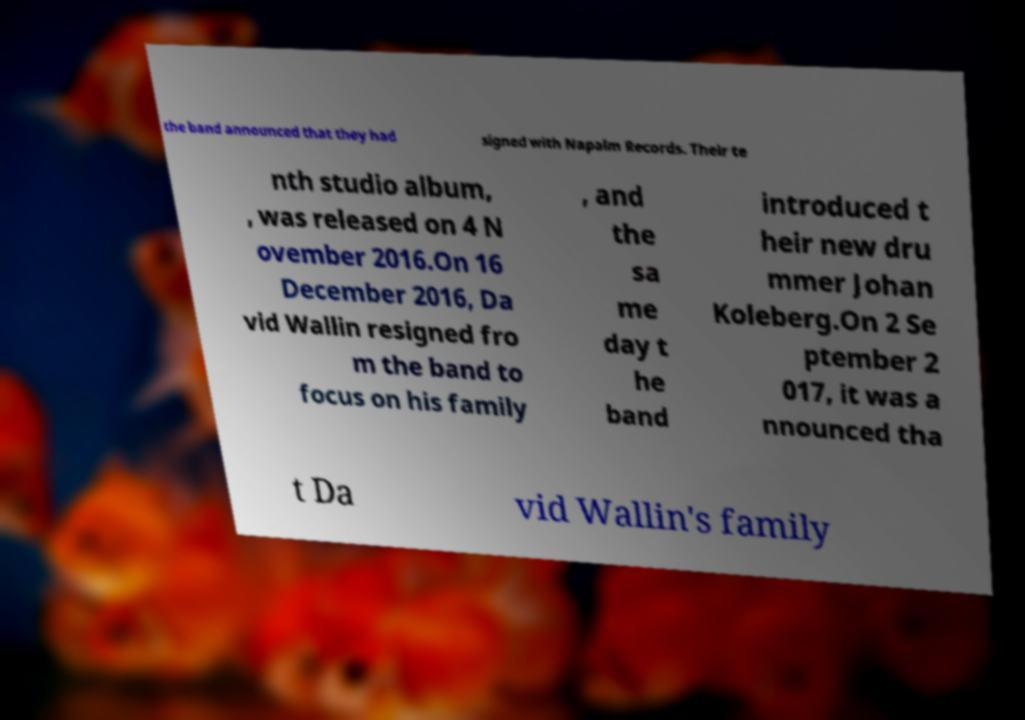Can you read and provide the text displayed in the image?This photo seems to have some interesting text. Can you extract and type it out for me? the band announced that they had signed with Napalm Records. Their te nth studio album, , was released on 4 N ovember 2016.On 16 December 2016, Da vid Wallin resigned fro m the band to focus on his family , and the sa me day t he band introduced t heir new dru mmer Johan Koleberg.On 2 Se ptember 2 017, it was a nnounced tha t Da vid Wallin's family 